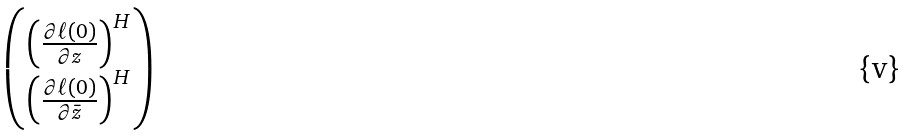<formula> <loc_0><loc_0><loc_500><loc_500>\begin{pmatrix} \left ( \frac { \partial \ell ( 0 ) } { \partial z } \right ) ^ { H } \\ \left ( \frac { \partial \ell ( 0 ) } { \partial \bar { z } } \right ) ^ { H } \end{pmatrix}</formula> 